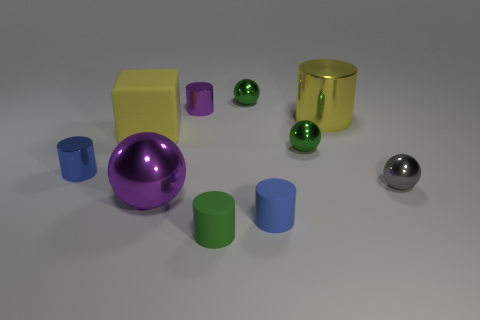Are there any blue metallic blocks that have the same size as the purple metallic cylinder?
Make the answer very short. No. There is a green ball that is in front of the purple metallic cylinder behind the green matte thing; what is its size?
Offer a terse response. Small. Are there fewer gray metallic spheres that are behind the tiny purple shiny thing than cylinders?
Your answer should be compact. Yes. Does the large cube have the same color as the big cylinder?
Offer a very short reply. Yes. What is the size of the green rubber thing?
Provide a short and direct response. Small. How many large rubber cubes are the same color as the large shiny cylinder?
Give a very brief answer. 1. There is a small blue thing that is on the left side of the tiny blue cylinder to the right of the green rubber thing; is there a large yellow metallic cylinder that is in front of it?
Provide a succinct answer. No. What is the shape of the purple thing that is the same size as the yellow block?
Offer a terse response. Sphere. What number of big objects are either blue cubes or gray things?
Keep it short and to the point. 0. There is a large ball that is made of the same material as the purple cylinder; what color is it?
Offer a terse response. Purple. 